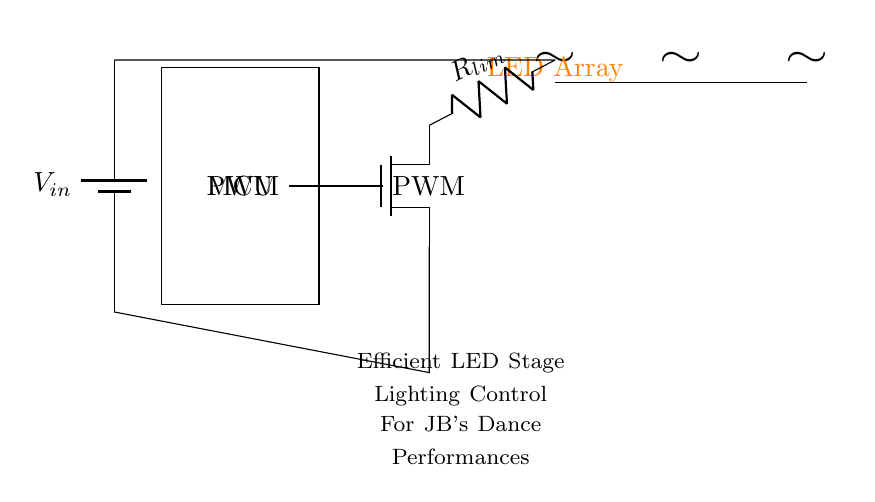What type of power supply is used in this circuit? The circuit uses a battery as indicated by the symbol and label for the power supply.
Answer: Battery What is the function of the PWM output in this circuit? The PWM output is utilized to control the brightness of the LED array by varying the duty cycle of the signal sent to the MOSFET.
Answer: Brightness control How many LEDs are present in the array? There are three individual LED components shown in the circuit diagram, indicating that the array consists of three LEDs.
Answer: Three What is the purpose of the current limiting resistor? The current limiting resistor is used to restrict the current flowing through the LED array to prevent damage due to excessive current.
Answer: Limit current How does the MOSFET influence the LED operation? The MOSFET acts as a switch that is controlled by the PWM output, allowing the circuit to modulate the LED brightness accordingly.
Answer: Acts as a switch What is the voltage input label in the circuit? The circuit diagram labels the voltage input as V in, indicating where the power is supplied to the circuit.
Answer: V in In which layer is the microcontroller located in the circuit? The microcontroller is depicted in the central position of the circuit diagram, connecting various components involved in controlling the LEDs.
Answer: Central layer 